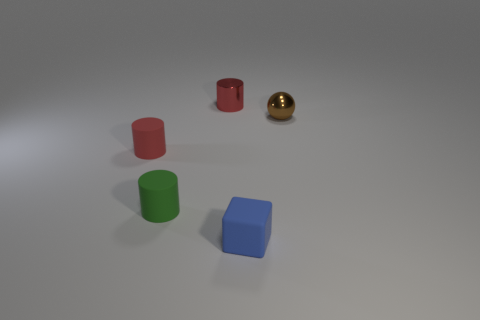What color is the small shiny object behind the small object that is to the right of the small blue cube?
Offer a terse response. Red. Does the small blue object have the same shape as the metal thing to the right of the metal cylinder?
Your response must be concise. No. The red thing to the left of the red object that is on the right side of the matte cylinder left of the green rubber thing is made of what material?
Keep it short and to the point. Rubber. Are there any green objects that have the same size as the brown sphere?
Keep it short and to the point. Yes. There is a red cylinder that is the same material as the brown ball; what size is it?
Your answer should be compact. Small. There is a tiny brown object; what shape is it?
Provide a succinct answer. Sphere. Is the small blue block made of the same material as the thing to the right of the tiny block?
Offer a terse response. No. How many objects are small green objects or small brown metallic objects?
Provide a short and direct response. 2. Are any yellow metallic spheres visible?
Offer a terse response. No. There is a small rubber thing that is to the right of the metallic object that is on the left side of the cube; what is its shape?
Offer a terse response. Cube. 